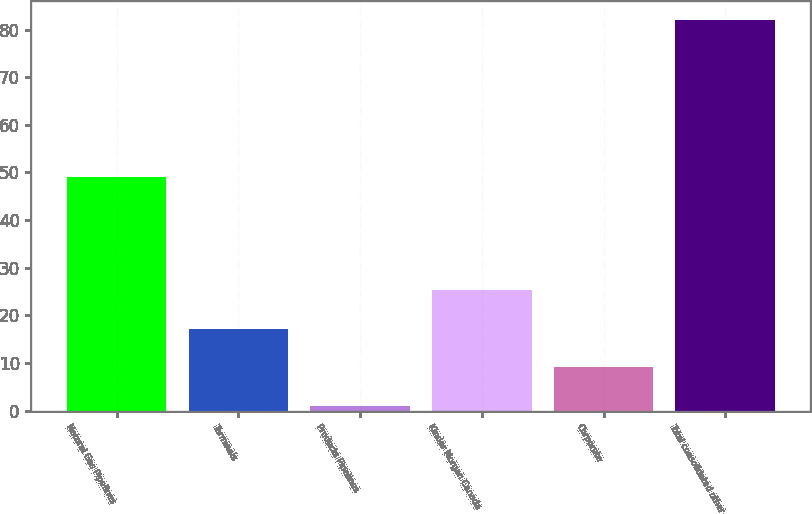<chart> <loc_0><loc_0><loc_500><loc_500><bar_chart><fcel>Natural Gas Pipelines<fcel>Terminals<fcel>Products Pipelines<fcel>Kinder Morgan Canada<fcel>Corporate<fcel>Total consolidated other<nl><fcel>49<fcel>17.2<fcel>1<fcel>25.3<fcel>9.1<fcel>82<nl></chart> 